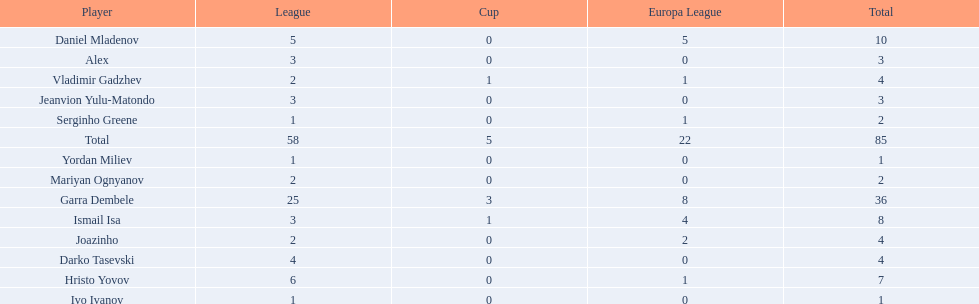Who are all of the players? Garra Dembele, Daniel Mladenov, Ismail Isa, Hristo Yovov, Joazinho, Vladimir Gadzhev, Darko Tasevski, Alex, Jeanvion Yulu-Matondo, Mariyan Ognyanov, Serginho Greene, Yordan Miliev, Ivo Ivanov. And which league is each player in? 25, 5, 3, 6, 2, 2, 4, 3, 3, 2, 1, 1, 1. Along with vladimir gadzhev and joazinho, which other player is in league 2? Mariyan Ognyanov. 